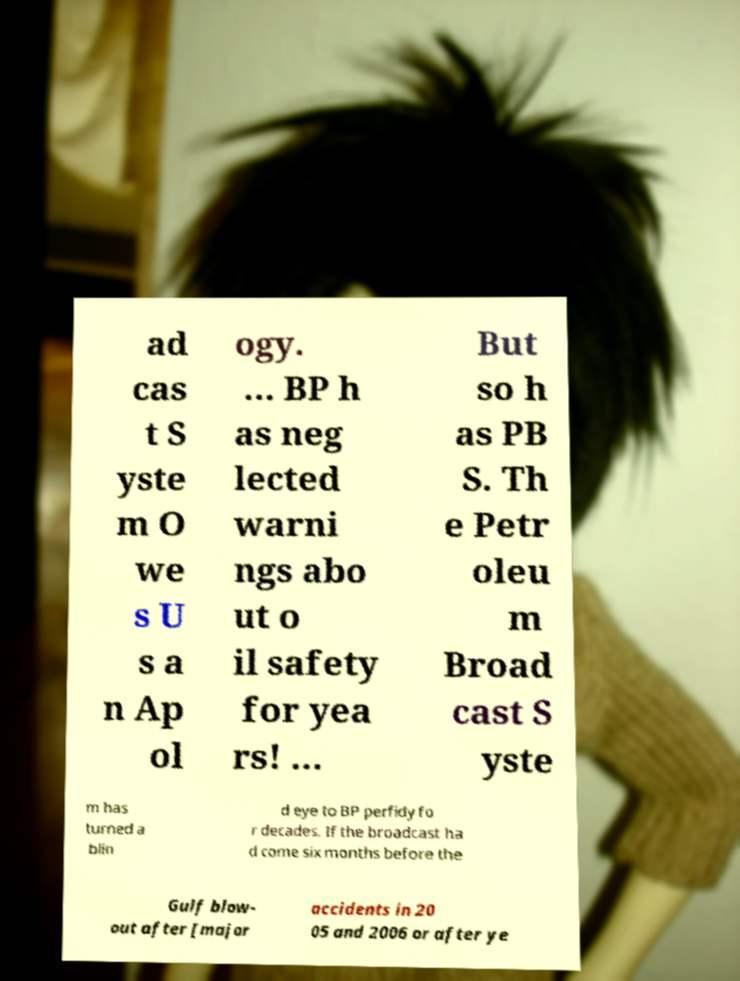Please identify and transcribe the text found in this image. ad cas t S yste m O we s U s a n Ap ol ogy. ... BP h as neg lected warni ngs abo ut o il safety for yea rs! ... But so h as PB S. Th e Petr oleu m Broad cast S yste m has turned a blin d eye to BP perfidy fo r decades. If the broadcast ha d come six months before the Gulf blow- out after [major accidents in 20 05 and 2006 or after ye 